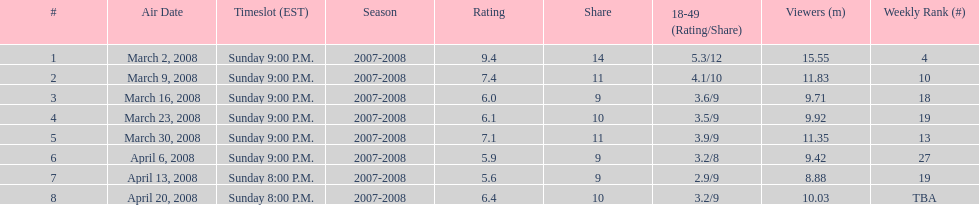Can you parse all the data within this table? {'header': ['#', 'Air Date', 'Timeslot (EST)', 'Season', 'Rating', 'Share', '18-49 (Rating/Share)', 'Viewers (m)', 'Weekly Rank (#)'], 'rows': [['1', 'March 2, 2008', 'Sunday 9:00 P.M.', '2007-2008', '9.4', '14', '5.3/12', '15.55', '4'], ['2', 'March 9, 2008', 'Sunday 9:00 P.M.', '2007-2008', '7.4', '11', '4.1/10', '11.83', '10'], ['3', 'March 16, 2008', 'Sunday 9:00 P.M.', '2007-2008', '6.0', '9', '3.6/9', '9.71', '18'], ['4', 'March 23, 2008', 'Sunday 9:00 P.M.', '2007-2008', '6.1', '10', '3.5/9', '9.92', '19'], ['5', 'March 30, 2008', 'Sunday 9:00 P.M.', '2007-2008', '7.1', '11', '3.9/9', '11.35', '13'], ['6', 'April 6, 2008', 'Sunday 9:00 P.M.', '2007-2008', '5.9', '9', '3.2/8', '9.42', '27'], ['7', 'April 13, 2008', 'Sunday 8:00 P.M.', '2007-2008', '5.6', '9', '2.9/9', '8.88', '19'], ['8', 'April 20, 2008', 'Sunday 8:00 P.M.', '2007-2008', '6.4', '10', '3.2/9', '10.03', 'TBA']]} How many shows had more than 10 million viewers? 4. 